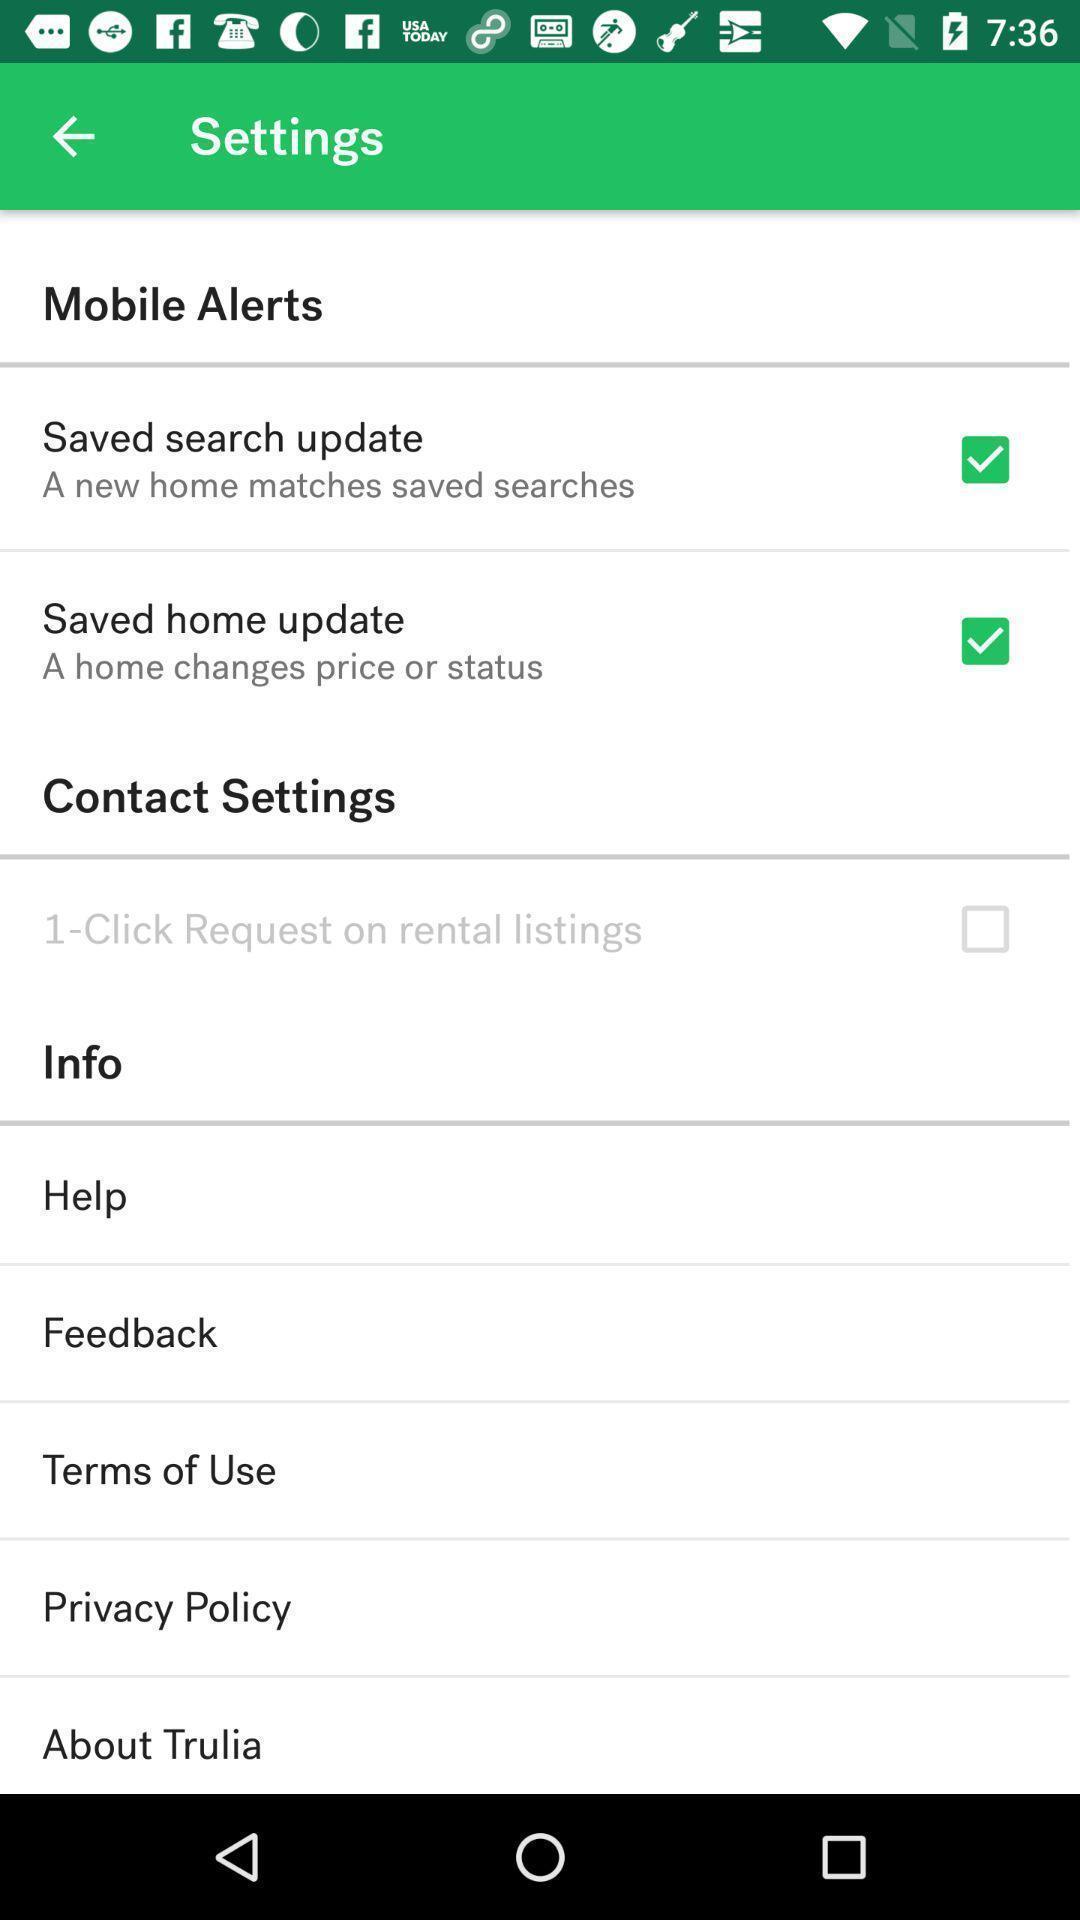Give me a summary of this screen capture. Page displaying the various options of settings. 